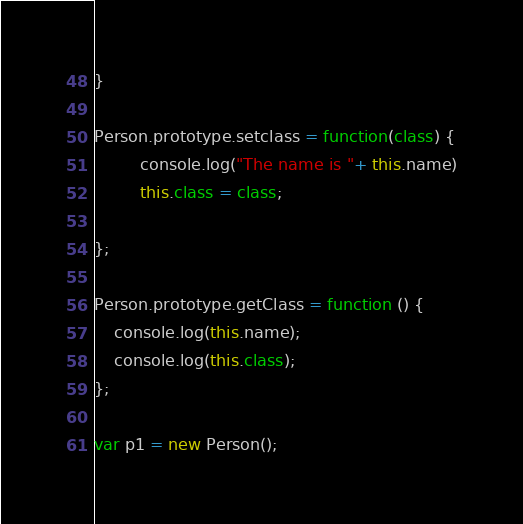Convert code to text. <code><loc_0><loc_0><loc_500><loc_500><_JavaScript_>}

Person.prototype.setclass = function(class) {
         console.log("The name is "+ this.name)
         this.class = class;

};

Person.prototype.getClass = function () {
    console.log(this.name);
    console.log(this.class);
};

var p1 = new Person();</code> 